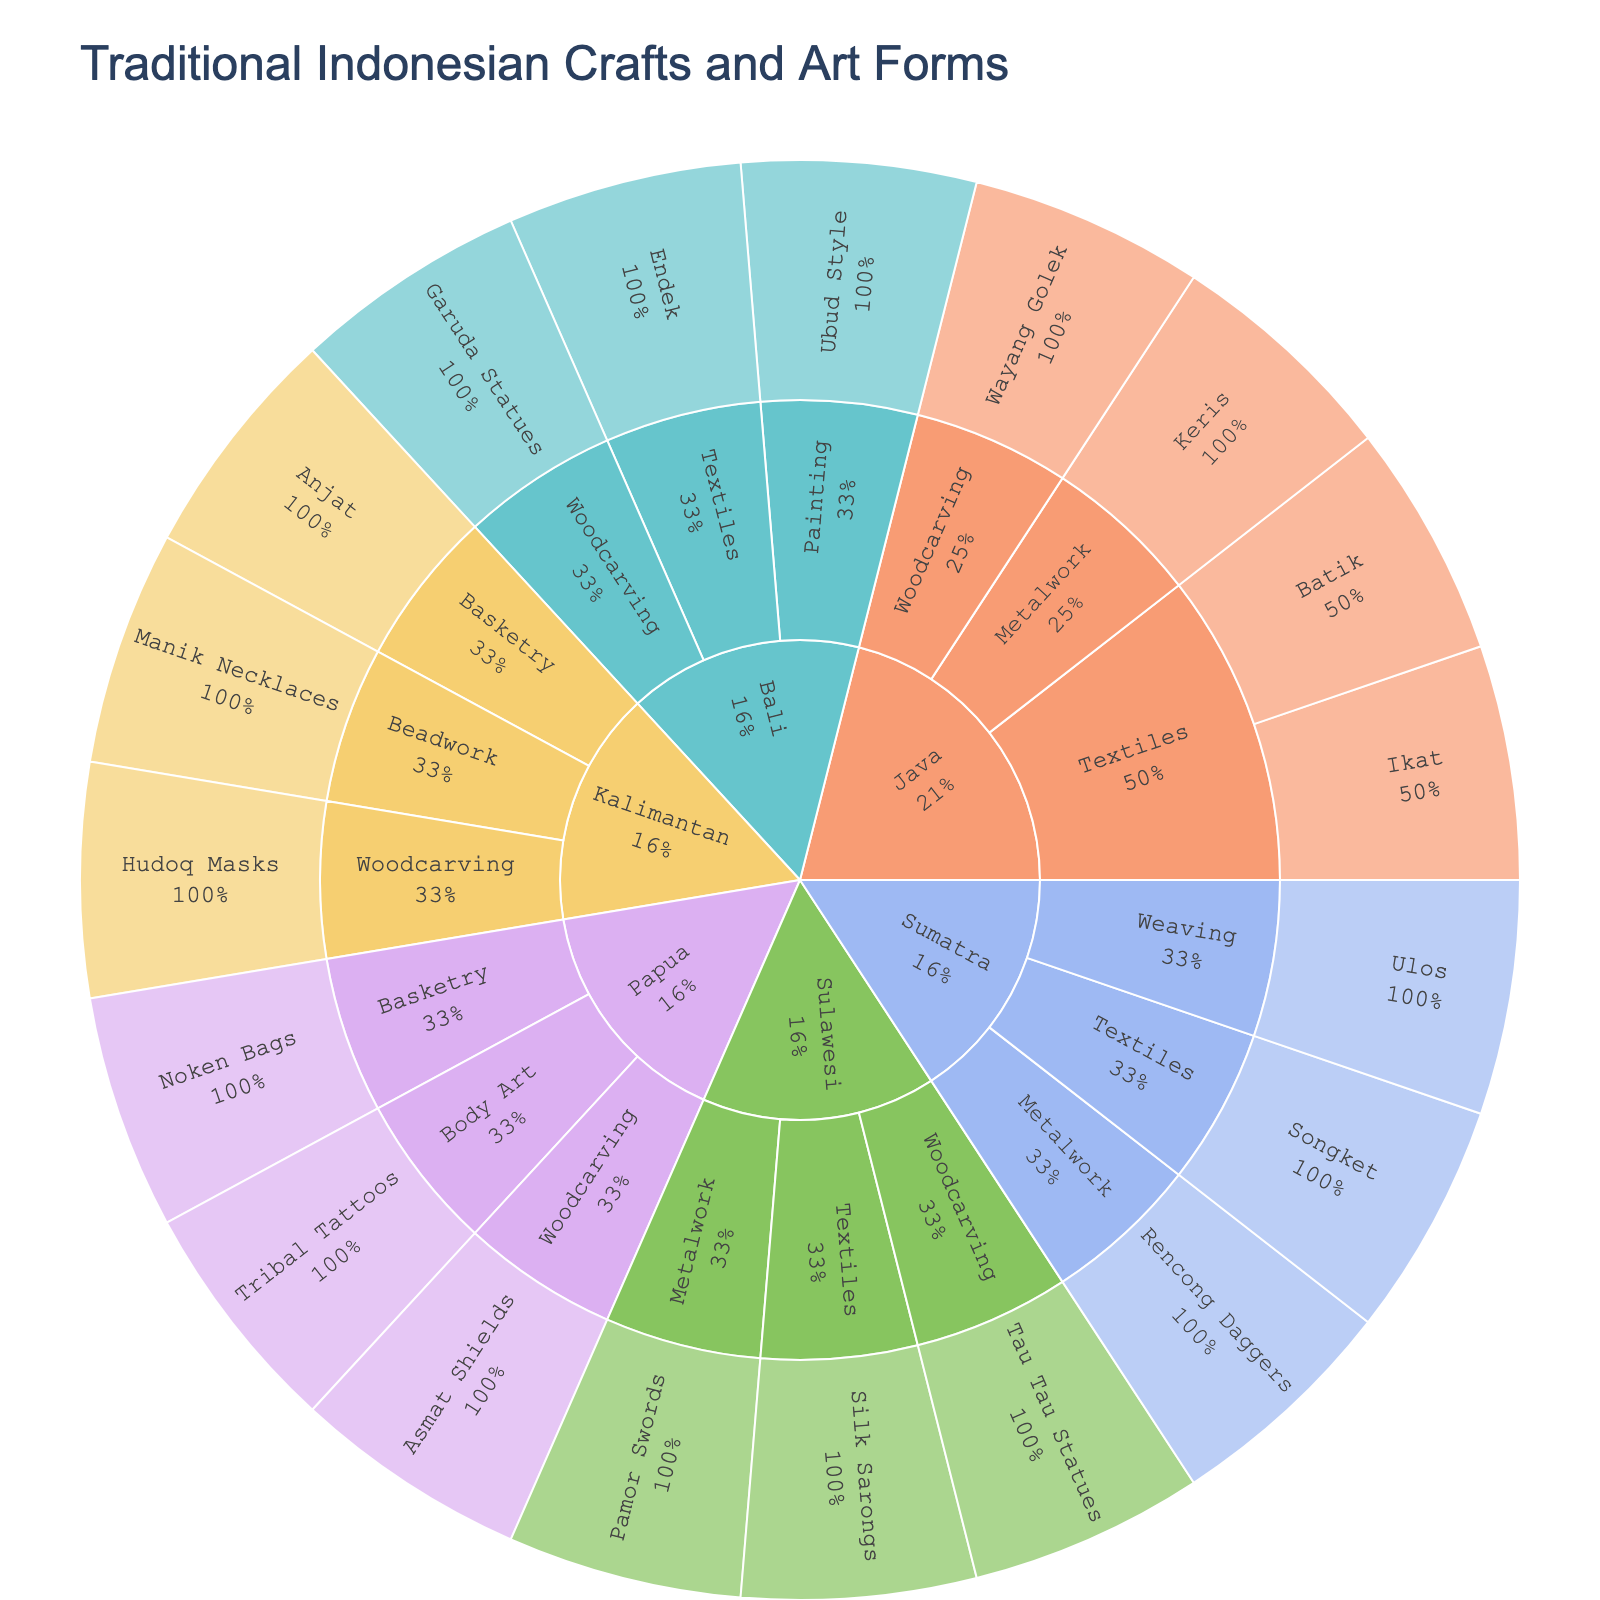How many regions are represented in the plot? The plot's outermost level shows the regions. By counting the number of unique regions in this level, we see the regions Java, Bali, Sumatra, Kalimantan, Sulawesi, and Papua.
Answer: 6 Which region has the most craft types listed? By counting the craft types under each region at the second level of the plot, we can see that both Java and Sumatra have more craft types (3 each) compared to other regions.
Answer: Java and Sumatra What percentage of crafts in Java are Textiles? In the plot, Java is divided into various craft types, including Textiles. Java has 4 crafts total, 2 of which are Textiles (Batik and Ikat). Therefore, the percentage is (2/4) * 100.
Answer: 50% What specific craft is found under Woodcarving in Sulawesi? By inspecting the branches under Woodcarving in Sulawesi within the plot, we find the specific craft listed as Tau Tau Statues.
Answer: Tau Tau Statues How does the number of crafts in Kalimantan compare to those in Papua? By counting the crafts in both the Kalimantan and Papua regions, Kalimantan has Anjat, Manik Necklaces, and Hudoq Masks (3 crafts) while Papua has Noken Bags, Asmat Shields, and Tribal Tattoos (3 crafts). They have the same number of crafts.
Answer: Equal Which region has the most examples of Textiles crafts? By counting the number of specific textiles crafts in each region: Java has Batik and Ikat (2), Bali has Endek (1), Sumatra has Songket (1), and Sulawesi has Silk Sarongs (1). Java has the most textile crafts.
Answer: Java What kind of craft is Ubud Style, and in which region is it found? Following the branches of the plot, Ubud Style is listed under Painting in the Bali region.
Answer: Painting in Bali How many specific crafts does the category of Metalwork include across all regions? By tallying the specific crafts listed under Metalwork in each region, there are 3 (Keris in Java, Rencong Daggers in Sumatra, and Pamor Swords in Sulawesi).
Answer: 3 Which regions have a craft type categorized as Basketry? Checking the regions that have Basketry as a craft type in the plot, we find that Kalimantan has Anjat and Papua has Noken Bags.
Answer: Kalimantan and Papua What is common about the crafts listed under Java? Observing the specific crafts listed under Java reveals that they include Batik, Ikat, Wayang Golek, and Keris, which are from different craft types (Textiles, Woodcarving, and Metalwork). They encompass a variety of different craft types.
Answer: Varied craft types 